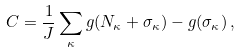Convert formula to latex. <formula><loc_0><loc_0><loc_500><loc_500>C = \frac { 1 } { J } \sum _ { \kappa } g ( N _ { \kappa } + \sigma _ { \kappa } ) - g ( \sigma _ { \kappa } ) \, ,</formula> 